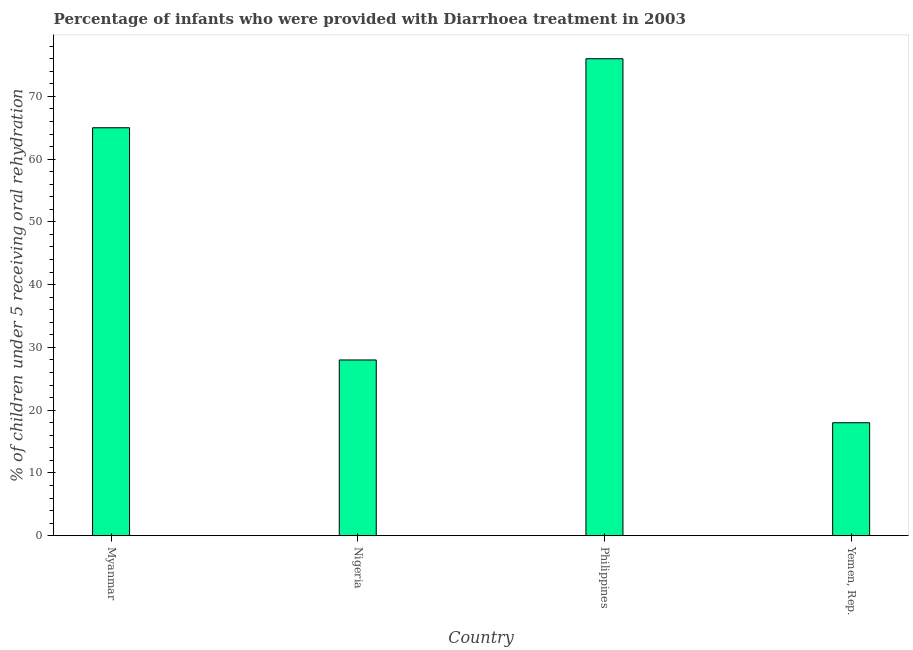What is the title of the graph?
Your answer should be very brief. Percentage of infants who were provided with Diarrhoea treatment in 2003. What is the label or title of the Y-axis?
Your answer should be very brief. % of children under 5 receiving oral rehydration. What is the percentage of children who were provided with treatment diarrhoea in Nigeria?
Ensure brevity in your answer.  28. Across all countries, what is the minimum percentage of children who were provided with treatment diarrhoea?
Offer a terse response. 18. In which country was the percentage of children who were provided with treatment diarrhoea maximum?
Keep it short and to the point. Philippines. In which country was the percentage of children who were provided with treatment diarrhoea minimum?
Offer a terse response. Yemen, Rep. What is the sum of the percentage of children who were provided with treatment diarrhoea?
Keep it short and to the point. 187. What is the difference between the percentage of children who were provided with treatment diarrhoea in Myanmar and Philippines?
Offer a very short reply. -11. What is the average percentage of children who were provided with treatment diarrhoea per country?
Give a very brief answer. 46. What is the median percentage of children who were provided with treatment diarrhoea?
Provide a succinct answer. 46.5. What is the ratio of the percentage of children who were provided with treatment diarrhoea in Nigeria to that in Yemen, Rep.?
Provide a short and direct response. 1.56. Is the percentage of children who were provided with treatment diarrhoea in Myanmar less than that in Philippines?
Ensure brevity in your answer.  Yes. Is the difference between the percentage of children who were provided with treatment diarrhoea in Philippines and Yemen, Rep. greater than the difference between any two countries?
Keep it short and to the point. Yes. What is the difference between the highest and the second highest percentage of children who were provided with treatment diarrhoea?
Offer a terse response. 11. Is the sum of the percentage of children who were provided with treatment diarrhoea in Nigeria and Philippines greater than the maximum percentage of children who were provided with treatment diarrhoea across all countries?
Give a very brief answer. Yes. What is the difference between the highest and the lowest percentage of children who were provided with treatment diarrhoea?
Keep it short and to the point. 58. In how many countries, is the percentage of children who were provided with treatment diarrhoea greater than the average percentage of children who were provided with treatment diarrhoea taken over all countries?
Offer a very short reply. 2. How many bars are there?
Make the answer very short. 4. How many countries are there in the graph?
Provide a succinct answer. 4. What is the % of children under 5 receiving oral rehydration of Myanmar?
Your answer should be compact. 65. What is the % of children under 5 receiving oral rehydration of Nigeria?
Your answer should be compact. 28. What is the % of children under 5 receiving oral rehydration of Philippines?
Provide a succinct answer. 76. What is the difference between the % of children under 5 receiving oral rehydration in Myanmar and Philippines?
Keep it short and to the point. -11. What is the difference between the % of children under 5 receiving oral rehydration in Myanmar and Yemen, Rep.?
Your answer should be very brief. 47. What is the difference between the % of children under 5 receiving oral rehydration in Nigeria and Philippines?
Your answer should be very brief. -48. What is the difference between the % of children under 5 receiving oral rehydration in Nigeria and Yemen, Rep.?
Provide a succinct answer. 10. What is the difference between the % of children under 5 receiving oral rehydration in Philippines and Yemen, Rep.?
Your answer should be compact. 58. What is the ratio of the % of children under 5 receiving oral rehydration in Myanmar to that in Nigeria?
Make the answer very short. 2.32. What is the ratio of the % of children under 5 receiving oral rehydration in Myanmar to that in Philippines?
Your response must be concise. 0.85. What is the ratio of the % of children under 5 receiving oral rehydration in Myanmar to that in Yemen, Rep.?
Provide a succinct answer. 3.61. What is the ratio of the % of children under 5 receiving oral rehydration in Nigeria to that in Philippines?
Give a very brief answer. 0.37. What is the ratio of the % of children under 5 receiving oral rehydration in Nigeria to that in Yemen, Rep.?
Your answer should be very brief. 1.56. What is the ratio of the % of children under 5 receiving oral rehydration in Philippines to that in Yemen, Rep.?
Your answer should be compact. 4.22. 